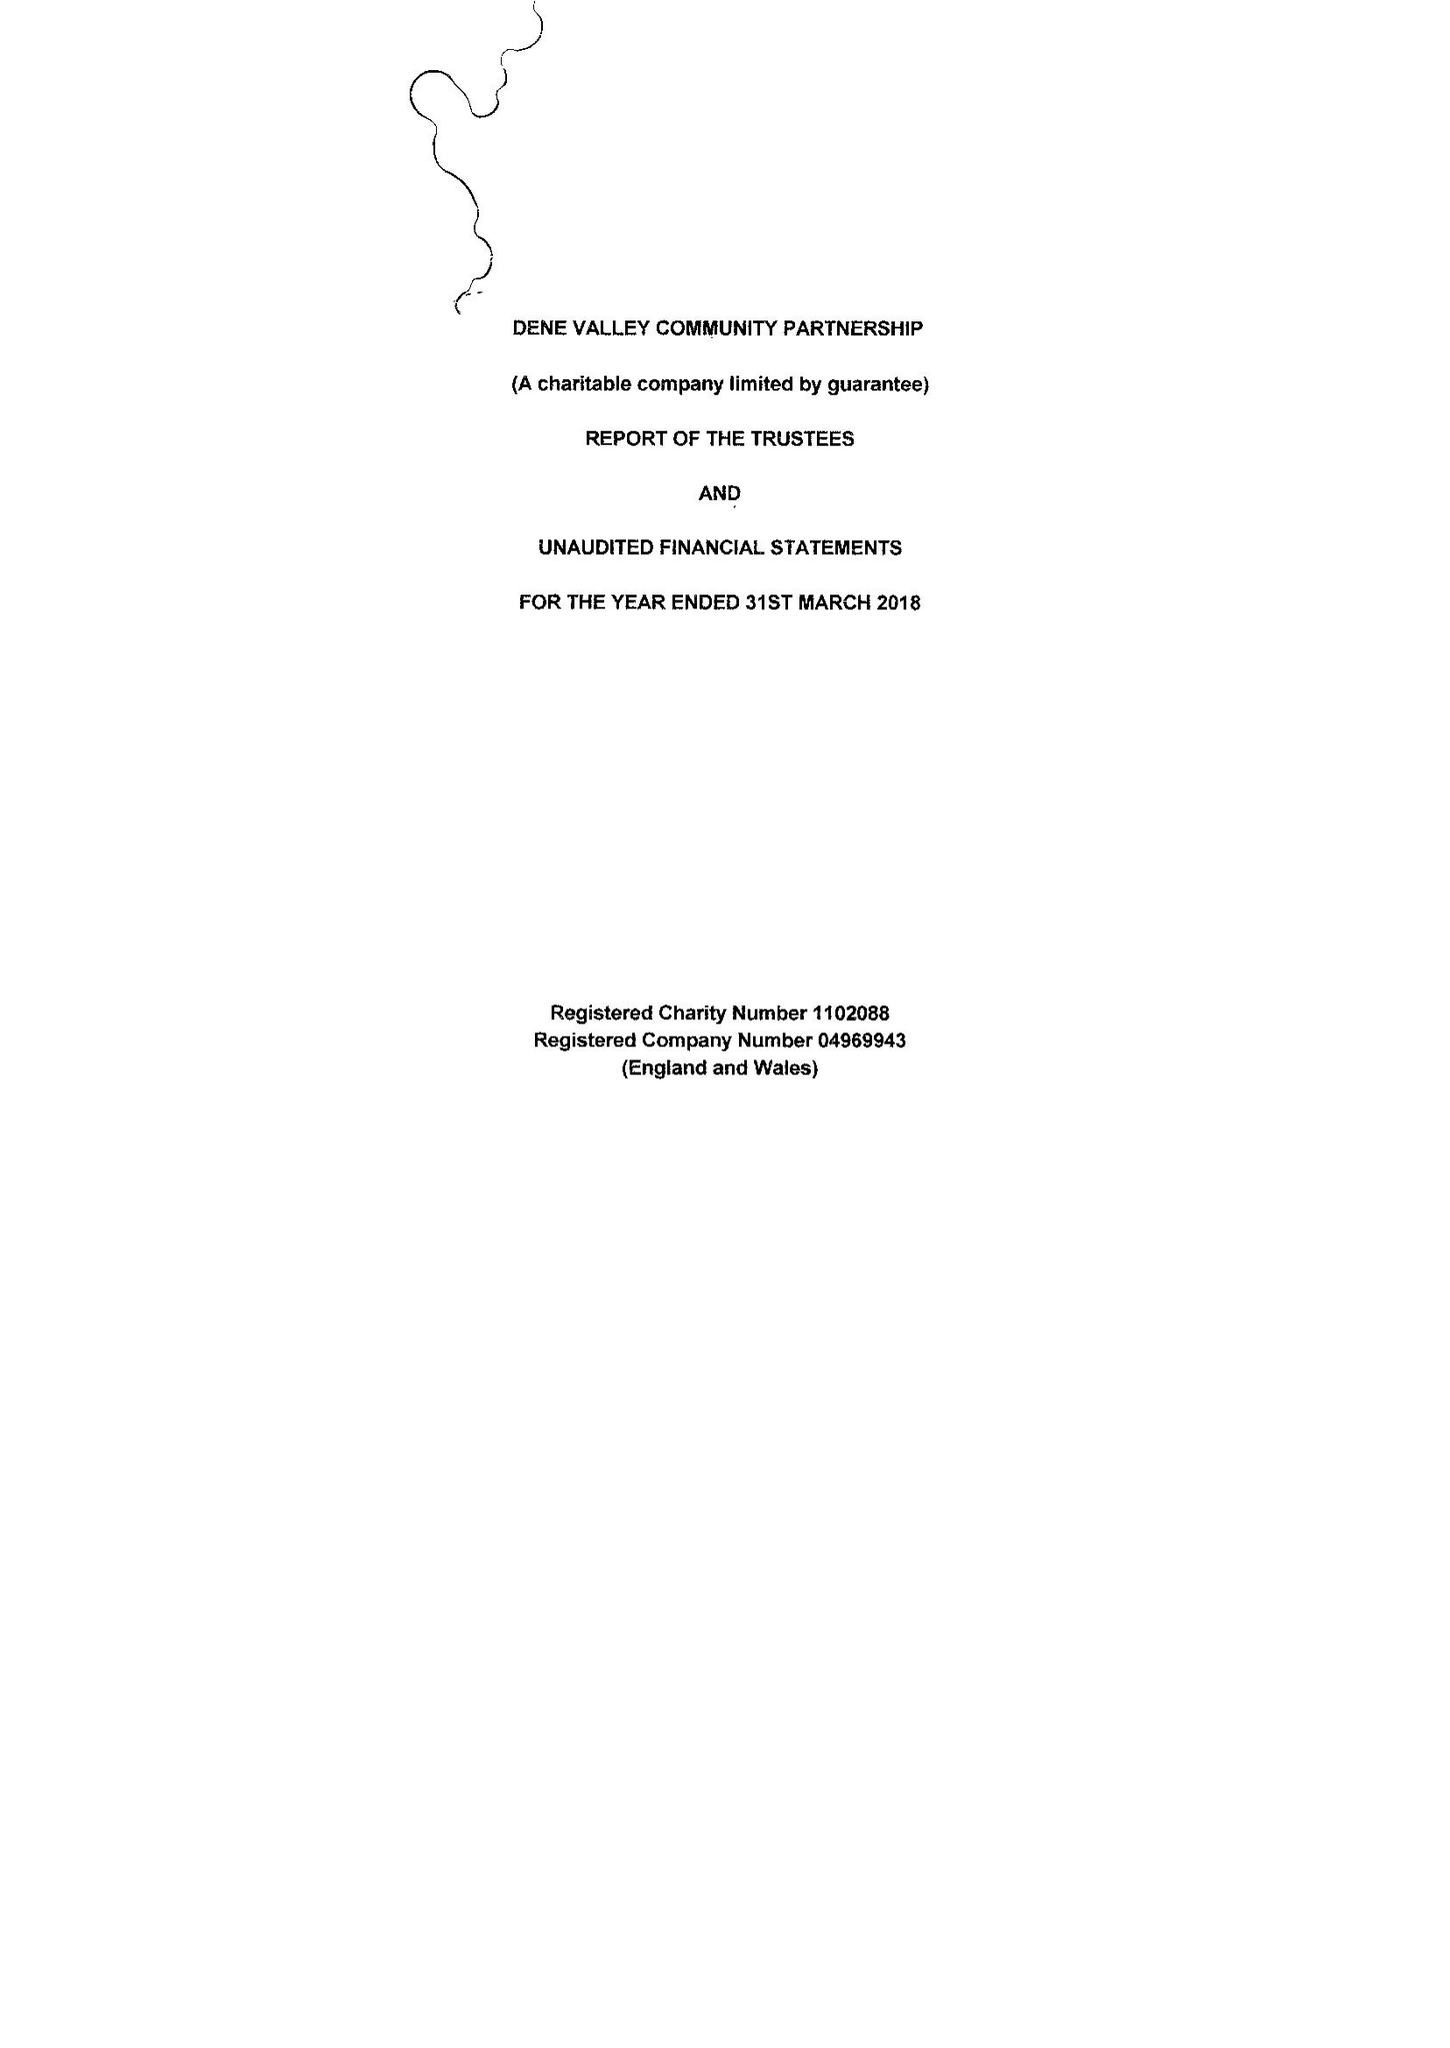What is the value for the charity_name?
Answer the question using a single word or phrase. Dene Valley Community Partnership 